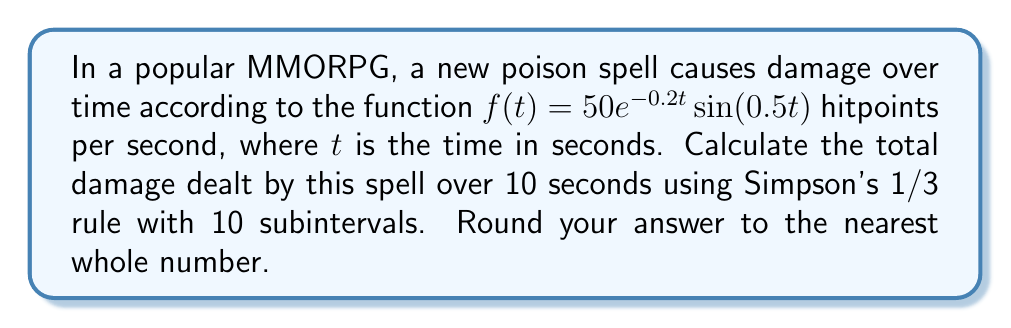Teach me how to tackle this problem. To solve this problem using Simpson's 1/3 rule, we'll follow these steps:

1) Simpson's 1/3 rule for n subintervals is given by:

   $$\int_{a}^{b} f(x) dx \approx \frac{h}{3}[f(x_0) + 4f(x_1) + 2f(x_2) + 4f(x_3) + ... + 2f(x_{n-2}) + 4f(x_{n-1}) + f(x_n)]$$

   where $h = \frac{b-a}{n}$, and $n$ must be even.

2) In our case, $a=0$, $b=10$, and $n=10$. So $h = \frac{10-0}{10} = 1$.

3) We need to calculate $f(x_i)$ for $i = 0, 1, ..., 10$:

   $f(x_i) = 50e^{-0.2x_i}\sin(0.5x_i)$

4) Let's calculate these values:
   
   $f(x_0) = f(0) = 0$
   $f(x_1) = f(1) \approx 20.0168$
   $f(x_2) = f(2) \approx 27.0671$
   $f(x_3) = f(3) \approx 24.5960$
   $f(x_4) = f(4) \approx 17.3205$
   $f(x_5) = f(5) \approx 9.5144$
   $f(x_6) = f(6) \approx 3.4920$
   $f(x_7) = f(7) \approx 0.1645$
   $f(x_8) = f(8) \approx -0.9179$
   $f(x_9) = f(9) \approx -0.8959$
   $f(x_{10}) = f(10) \approx -0.4161$

5) Now, let's apply Simpson's 1/3 rule:

   $$\frac{1}{3}[0 + 4(20.0168) + 2(27.0671) + 4(24.5960) + 2(17.3205) + 4(9.5144) + 2(3.4920) + 4(0.1645) + 2(-0.9179) + 4(-0.8959) + (-0.4161)]$$

6) Simplifying:

   $$\frac{1}{3}[0 + 80.0672 + 54.1342 + 98.3840 + 34.6410 + 38.0576 + 6.9840 + 0.6580 - 1.8358 - 3.5836 - 0.4161] = 102.3635$$

7) Rounding to the nearest whole number: 102
Answer: 102 hitpoints 